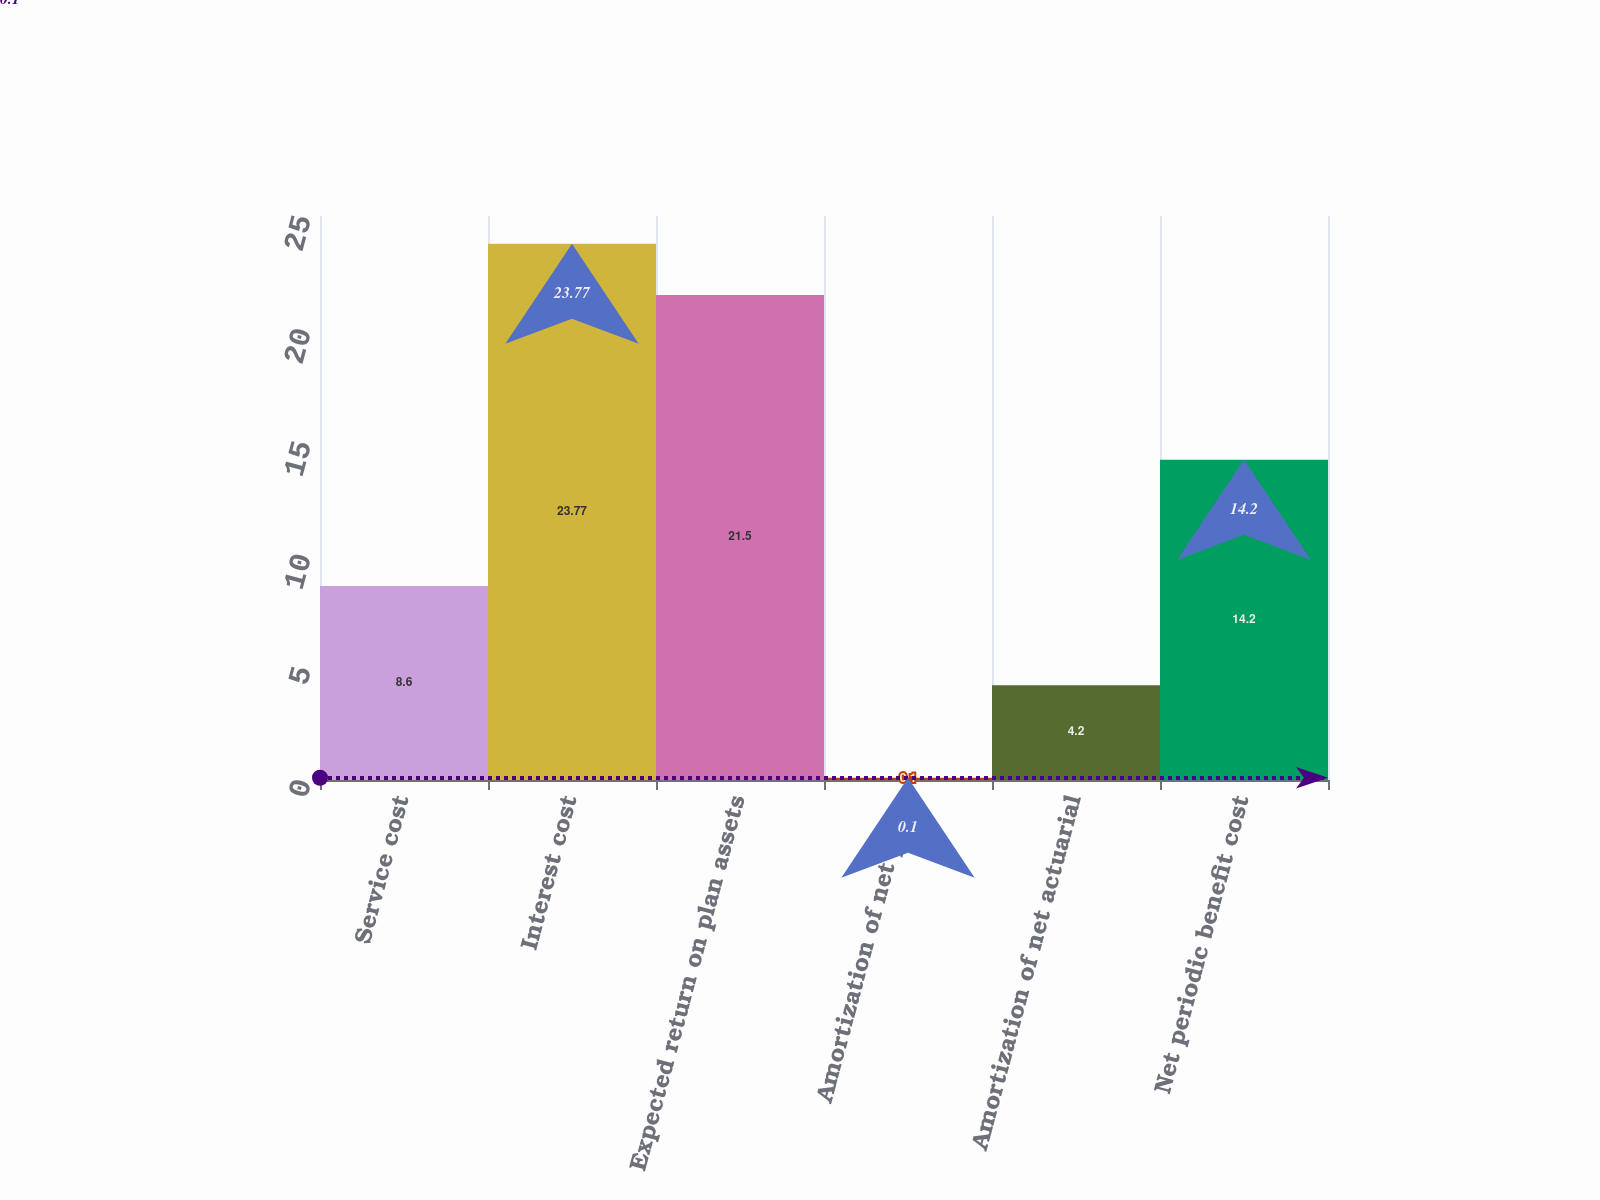Convert chart. <chart><loc_0><loc_0><loc_500><loc_500><bar_chart><fcel>Service cost<fcel>Interest cost<fcel>Expected return on plan assets<fcel>Amortization of net prior<fcel>Amortization of net actuarial<fcel>Net periodic benefit cost<nl><fcel>8.6<fcel>23.77<fcel>21.5<fcel>0.1<fcel>4.2<fcel>14.2<nl></chart> 